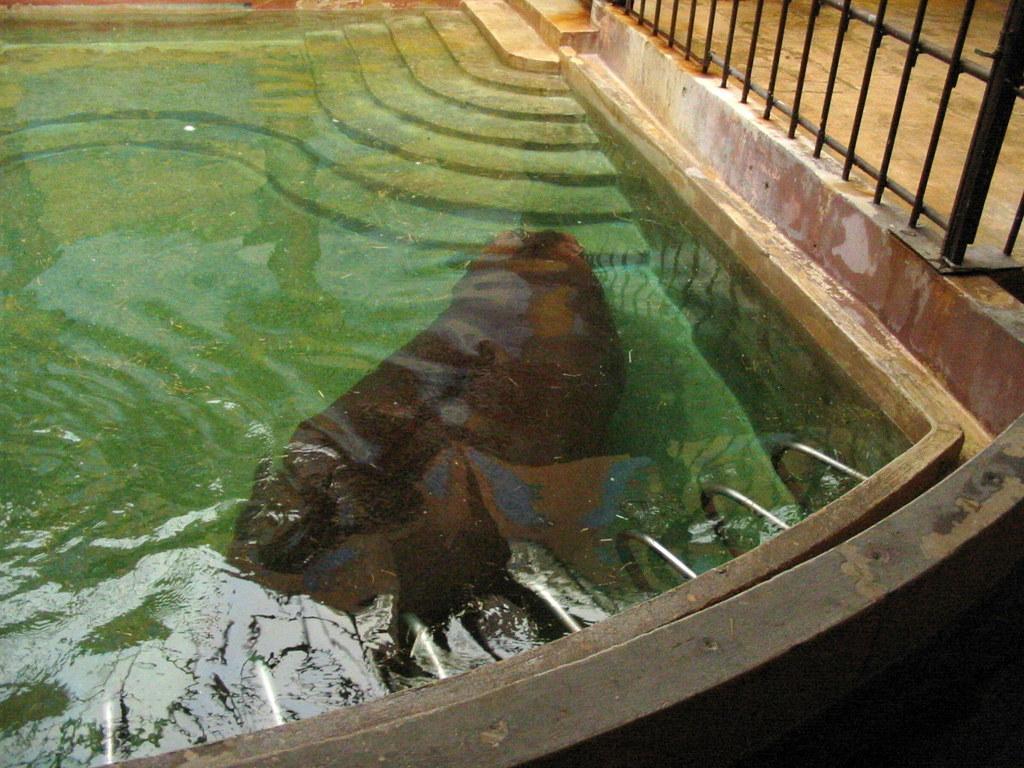Describe this image in one or two sentences. There is a sea animal in the water pond. In the background, there are steps, there is a fencing and there is a road. 